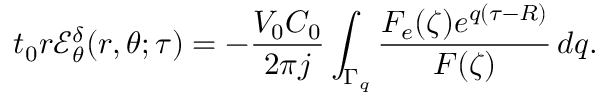<formula> <loc_0><loc_0><loc_500><loc_500>t _ { 0 } r \mathcal { E } _ { \theta } ^ { \delta } ( r , \theta ; \tau ) = - \frac { V _ { 0 } C _ { 0 } } { 2 \pi j } \int _ { \Gamma _ { q } } \frac { F _ { e } ( \zeta ) e ^ { q ( \tau - R ) } } { F ( \zeta ) } \, d q .</formula> 